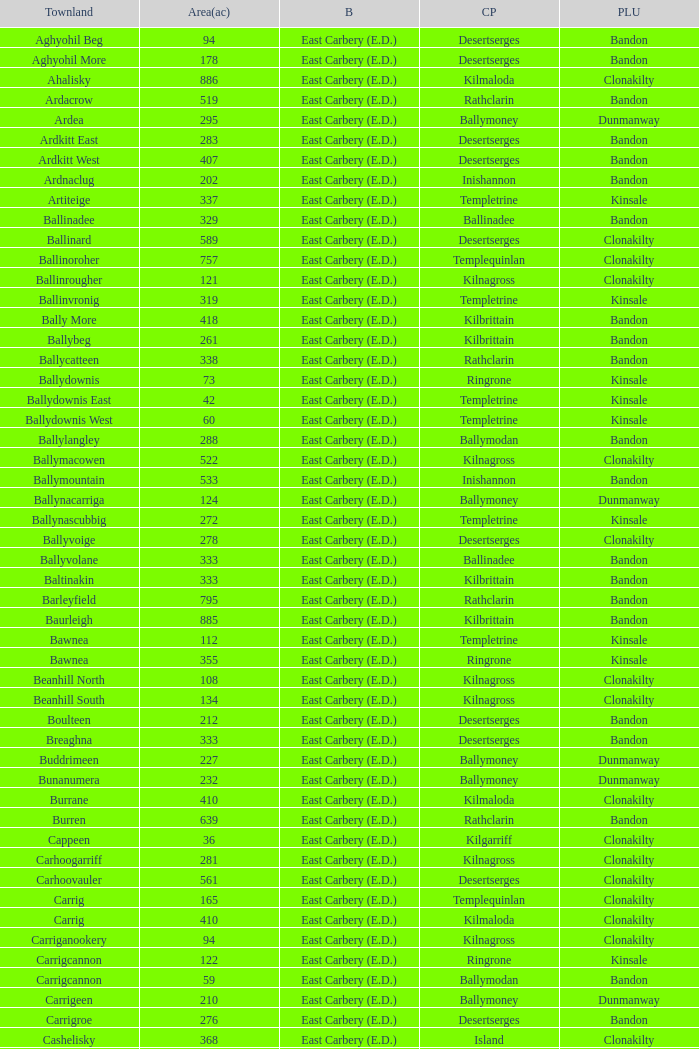What is the poor law union of the Ardacrow townland? Bandon. 